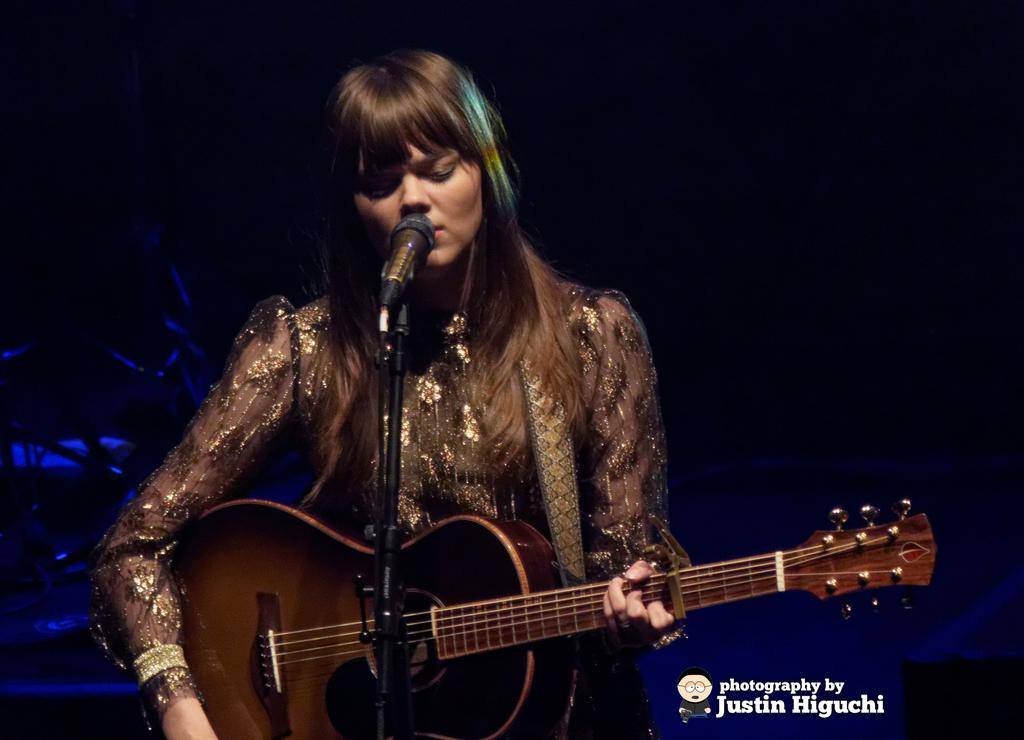Who is the main subject in the image? There is a woman in the image. What is the woman doing in the image? The woman is playing a guitar. What object is present in the image that might be used for amplifying her voice? There is a microphone in the image. What type of vessel is being used by the woman to store her guitar picks in the image? There is no vessel present in the image, and the woman is not shown using any guitar picks. 